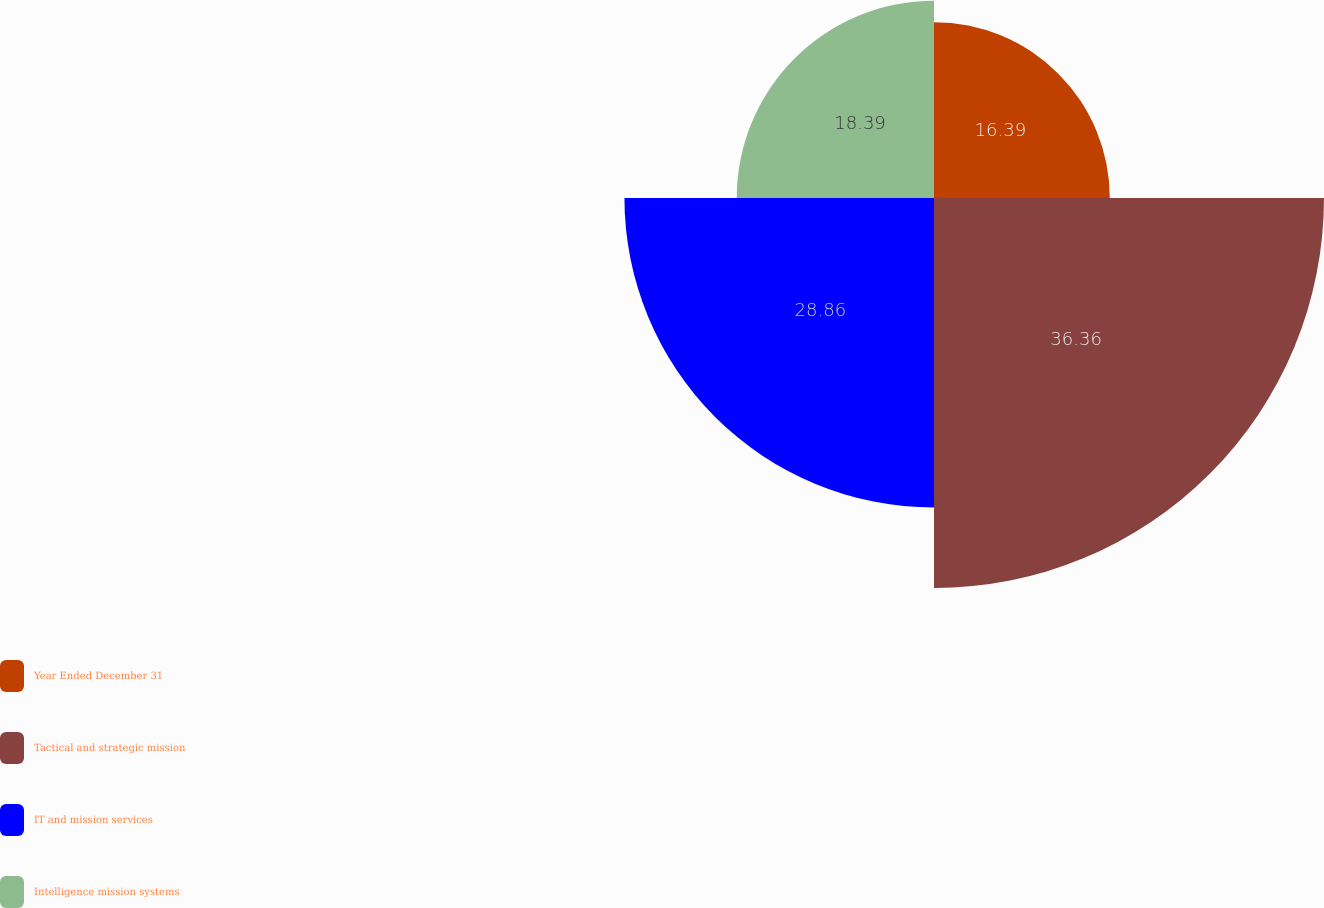Convert chart to OTSL. <chart><loc_0><loc_0><loc_500><loc_500><pie_chart><fcel>Year Ended December 31<fcel>Tactical and strategic mission<fcel>IT and mission services<fcel>Intelligence mission systems<nl><fcel>16.39%<fcel>36.36%<fcel>28.86%<fcel>18.39%<nl></chart> 